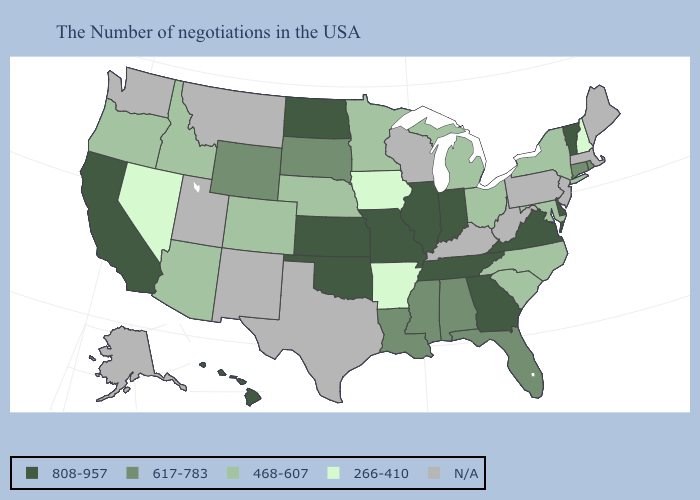What is the value of Arizona?
Give a very brief answer. 468-607. What is the value of Texas?
Give a very brief answer. N/A. Among the states that border New Mexico , does Oklahoma have the lowest value?
Answer briefly. No. What is the value of Texas?
Short answer required. N/A. What is the lowest value in the MidWest?
Concise answer only. 266-410. Among the states that border Oregon , which have the highest value?
Be succinct. California. Which states have the lowest value in the USA?
Give a very brief answer. New Hampshire, Arkansas, Iowa, Nevada. Which states have the lowest value in the USA?
Write a very short answer. New Hampshire, Arkansas, Iowa, Nevada. What is the value of New Mexico?
Write a very short answer. N/A. What is the value of Connecticut?
Concise answer only. 617-783. Does Mississippi have the lowest value in the USA?
Give a very brief answer. No. What is the value of Utah?
Give a very brief answer. N/A. Does the map have missing data?
Concise answer only. Yes. Among the states that border Arkansas , which have the highest value?
Keep it brief. Tennessee, Missouri, Oklahoma. Name the states that have a value in the range 617-783?
Give a very brief answer. Rhode Island, Connecticut, Florida, Alabama, Mississippi, Louisiana, South Dakota, Wyoming. 